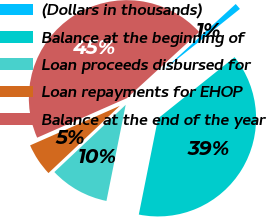Convert chart to OTSL. <chart><loc_0><loc_0><loc_500><loc_500><pie_chart><fcel>(Dollars in thousands)<fcel>Balance at the beginning of<fcel>Loan proceeds disbursed for<fcel>Loan repayments for EHOP<fcel>Balance at the end of the year<nl><fcel>1.05%<fcel>38.89%<fcel>9.83%<fcel>5.42%<fcel>44.81%<nl></chart> 